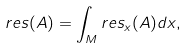<formula> <loc_0><loc_0><loc_500><loc_500>r e s ( A ) & = \int _ { M } r e s _ { x } ( A ) d x ,</formula> 